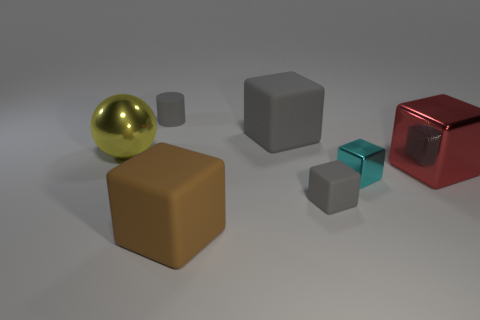Subtract all small metallic blocks. How many blocks are left? 4 Subtract all brown cubes. How many cubes are left? 4 Subtract 1 blocks. How many blocks are left? 4 Subtract 1 yellow spheres. How many objects are left? 6 Subtract all spheres. How many objects are left? 6 Subtract all blue balls. Subtract all brown cubes. How many balls are left? 1 Subtract all purple spheres. How many gray blocks are left? 2 Subtract all yellow rubber blocks. Subtract all small cubes. How many objects are left? 5 Add 4 large shiny blocks. How many large shiny blocks are left? 5 Add 6 yellow objects. How many yellow objects exist? 7 